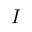Convert formula to latex. <formula><loc_0><loc_0><loc_500><loc_500>I</formula> 